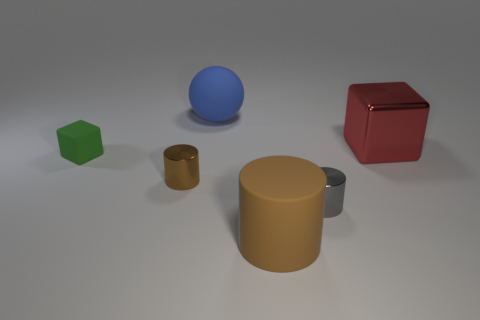What number of other small cylinders have the same color as the rubber cylinder?
Provide a short and direct response. 1. The gray shiny object that is the same shape as the small brown metal object is what size?
Provide a short and direct response. Small. Are there any other things that have the same shape as the large blue rubber thing?
Provide a succinct answer. No. Is the number of gray metallic cylinders greater than the number of large purple balls?
Your response must be concise. Yes. How many tiny things are in front of the tiny green rubber cube and to the left of the blue rubber sphere?
Provide a short and direct response. 1. There is a large matte thing that is behind the large brown matte cylinder; how many tiny brown objects are in front of it?
Offer a terse response. 1. There is a brown object behind the large brown thing; is it the same size as the cube to the right of the brown matte object?
Provide a short and direct response. No. How many small green matte cubes are there?
Your answer should be compact. 1. How many green things have the same material as the big block?
Your answer should be very brief. 0. Is the number of tiny matte blocks to the right of the large metal block the same as the number of big gray metal objects?
Ensure brevity in your answer.  Yes. 